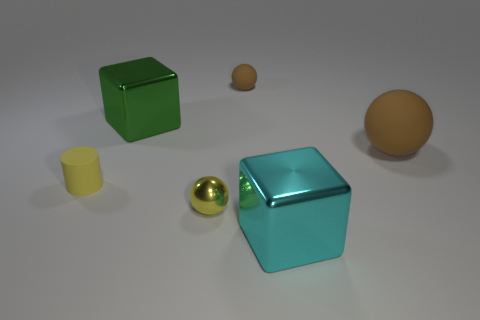Add 2 green metallic objects. How many objects exist? 8 Subtract all cubes. How many objects are left? 4 Subtract 0 cyan cylinders. How many objects are left? 6 Subtract all yellow balls. Subtract all blue shiny spheres. How many objects are left? 5 Add 3 yellow balls. How many yellow balls are left? 4 Add 2 big red metallic spheres. How many big red metallic spheres exist? 2 